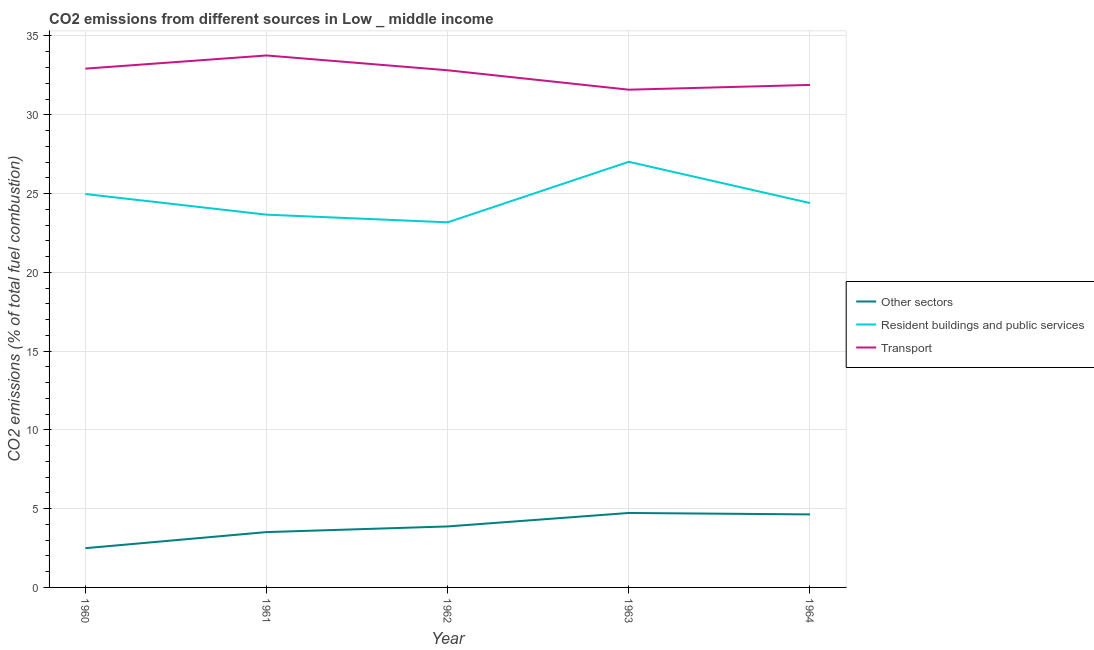Does the line corresponding to percentage of co2 emissions from resident buildings and public services intersect with the line corresponding to percentage of co2 emissions from transport?
Keep it short and to the point. No. Is the number of lines equal to the number of legend labels?
Make the answer very short. Yes. What is the percentage of co2 emissions from other sectors in 1960?
Ensure brevity in your answer.  2.49. Across all years, what is the maximum percentage of co2 emissions from other sectors?
Offer a terse response. 4.73. Across all years, what is the minimum percentage of co2 emissions from other sectors?
Your answer should be compact. 2.49. In which year was the percentage of co2 emissions from transport minimum?
Provide a succinct answer. 1963. What is the total percentage of co2 emissions from resident buildings and public services in the graph?
Keep it short and to the point. 123.22. What is the difference between the percentage of co2 emissions from transport in 1963 and that in 1964?
Your answer should be very brief. -0.3. What is the difference between the percentage of co2 emissions from other sectors in 1964 and the percentage of co2 emissions from transport in 1961?
Make the answer very short. -29.13. What is the average percentage of co2 emissions from other sectors per year?
Make the answer very short. 3.85. In the year 1960, what is the difference between the percentage of co2 emissions from resident buildings and public services and percentage of co2 emissions from other sectors?
Provide a succinct answer. 22.48. What is the ratio of the percentage of co2 emissions from transport in 1961 to that in 1963?
Ensure brevity in your answer.  1.07. Is the percentage of co2 emissions from other sectors in 1961 less than that in 1964?
Your answer should be very brief. Yes. Is the difference between the percentage of co2 emissions from other sectors in 1961 and 1963 greater than the difference between the percentage of co2 emissions from transport in 1961 and 1963?
Ensure brevity in your answer.  No. What is the difference between the highest and the second highest percentage of co2 emissions from other sectors?
Your response must be concise. 0.09. What is the difference between the highest and the lowest percentage of co2 emissions from resident buildings and public services?
Ensure brevity in your answer.  3.84. Is the sum of the percentage of co2 emissions from resident buildings and public services in 1960 and 1961 greater than the maximum percentage of co2 emissions from transport across all years?
Your answer should be compact. Yes. Is the percentage of co2 emissions from other sectors strictly greater than the percentage of co2 emissions from resident buildings and public services over the years?
Ensure brevity in your answer.  No. How many lines are there?
Offer a terse response. 3. How many years are there in the graph?
Provide a short and direct response. 5. What is the difference between two consecutive major ticks on the Y-axis?
Provide a short and direct response. 5. Does the graph contain grids?
Keep it short and to the point. Yes. Where does the legend appear in the graph?
Provide a short and direct response. Center right. How many legend labels are there?
Provide a succinct answer. 3. What is the title of the graph?
Your answer should be compact. CO2 emissions from different sources in Low _ middle income. What is the label or title of the X-axis?
Give a very brief answer. Year. What is the label or title of the Y-axis?
Your answer should be compact. CO2 emissions (% of total fuel combustion). What is the CO2 emissions (% of total fuel combustion) in Other sectors in 1960?
Your answer should be compact. 2.49. What is the CO2 emissions (% of total fuel combustion) in Resident buildings and public services in 1960?
Offer a terse response. 24.97. What is the CO2 emissions (% of total fuel combustion) of Transport in 1960?
Ensure brevity in your answer.  32.93. What is the CO2 emissions (% of total fuel combustion) in Other sectors in 1961?
Offer a very short reply. 3.51. What is the CO2 emissions (% of total fuel combustion) of Resident buildings and public services in 1961?
Offer a very short reply. 23.66. What is the CO2 emissions (% of total fuel combustion) in Transport in 1961?
Provide a succinct answer. 33.76. What is the CO2 emissions (% of total fuel combustion) in Other sectors in 1962?
Offer a very short reply. 3.87. What is the CO2 emissions (% of total fuel combustion) in Resident buildings and public services in 1962?
Your answer should be very brief. 23.17. What is the CO2 emissions (% of total fuel combustion) in Transport in 1962?
Your response must be concise. 32.82. What is the CO2 emissions (% of total fuel combustion) of Other sectors in 1963?
Offer a very short reply. 4.73. What is the CO2 emissions (% of total fuel combustion) in Resident buildings and public services in 1963?
Offer a terse response. 27.01. What is the CO2 emissions (% of total fuel combustion) in Transport in 1963?
Ensure brevity in your answer.  31.59. What is the CO2 emissions (% of total fuel combustion) of Other sectors in 1964?
Offer a terse response. 4.63. What is the CO2 emissions (% of total fuel combustion) in Resident buildings and public services in 1964?
Keep it short and to the point. 24.4. What is the CO2 emissions (% of total fuel combustion) of Transport in 1964?
Your answer should be very brief. 31.89. Across all years, what is the maximum CO2 emissions (% of total fuel combustion) of Other sectors?
Give a very brief answer. 4.73. Across all years, what is the maximum CO2 emissions (% of total fuel combustion) of Resident buildings and public services?
Your answer should be very brief. 27.01. Across all years, what is the maximum CO2 emissions (% of total fuel combustion) in Transport?
Your response must be concise. 33.76. Across all years, what is the minimum CO2 emissions (% of total fuel combustion) of Other sectors?
Your answer should be compact. 2.49. Across all years, what is the minimum CO2 emissions (% of total fuel combustion) of Resident buildings and public services?
Ensure brevity in your answer.  23.17. Across all years, what is the minimum CO2 emissions (% of total fuel combustion) in Transport?
Provide a short and direct response. 31.59. What is the total CO2 emissions (% of total fuel combustion) of Other sectors in the graph?
Make the answer very short. 19.23. What is the total CO2 emissions (% of total fuel combustion) in Resident buildings and public services in the graph?
Provide a short and direct response. 123.22. What is the total CO2 emissions (% of total fuel combustion) of Transport in the graph?
Make the answer very short. 163. What is the difference between the CO2 emissions (% of total fuel combustion) of Other sectors in 1960 and that in 1961?
Your response must be concise. -1.02. What is the difference between the CO2 emissions (% of total fuel combustion) of Resident buildings and public services in 1960 and that in 1961?
Provide a short and direct response. 1.31. What is the difference between the CO2 emissions (% of total fuel combustion) of Transport in 1960 and that in 1961?
Your response must be concise. -0.84. What is the difference between the CO2 emissions (% of total fuel combustion) in Other sectors in 1960 and that in 1962?
Make the answer very short. -1.38. What is the difference between the CO2 emissions (% of total fuel combustion) in Resident buildings and public services in 1960 and that in 1962?
Make the answer very short. 1.8. What is the difference between the CO2 emissions (% of total fuel combustion) of Transport in 1960 and that in 1962?
Give a very brief answer. 0.1. What is the difference between the CO2 emissions (% of total fuel combustion) in Other sectors in 1960 and that in 1963?
Make the answer very short. -2.24. What is the difference between the CO2 emissions (% of total fuel combustion) of Resident buildings and public services in 1960 and that in 1963?
Provide a short and direct response. -2.05. What is the difference between the CO2 emissions (% of total fuel combustion) of Transport in 1960 and that in 1963?
Your response must be concise. 1.34. What is the difference between the CO2 emissions (% of total fuel combustion) in Other sectors in 1960 and that in 1964?
Give a very brief answer. -2.14. What is the difference between the CO2 emissions (% of total fuel combustion) of Resident buildings and public services in 1960 and that in 1964?
Provide a succinct answer. 0.57. What is the difference between the CO2 emissions (% of total fuel combustion) in Transport in 1960 and that in 1964?
Offer a very short reply. 1.03. What is the difference between the CO2 emissions (% of total fuel combustion) in Other sectors in 1961 and that in 1962?
Keep it short and to the point. -0.36. What is the difference between the CO2 emissions (% of total fuel combustion) in Resident buildings and public services in 1961 and that in 1962?
Give a very brief answer. 0.49. What is the difference between the CO2 emissions (% of total fuel combustion) of Transport in 1961 and that in 1962?
Offer a terse response. 0.94. What is the difference between the CO2 emissions (% of total fuel combustion) of Other sectors in 1961 and that in 1963?
Offer a terse response. -1.21. What is the difference between the CO2 emissions (% of total fuel combustion) in Resident buildings and public services in 1961 and that in 1963?
Offer a very short reply. -3.35. What is the difference between the CO2 emissions (% of total fuel combustion) of Transport in 1961 and that in 1963?
Your response must be concise. 2.17. What is the difference between the CO2 emissions (% of total fuel combustion) in Other sectors in 1961 and that in 1964?
Your response must be concise. -1.12. What is the difference between the CO2 emissions (% of total fuel combustion) in Resident buildings and public services in 1961 and that in 1964?
Your answer should be very brief. -0.74. What is the difference between the CO2 emissions (% of total fuel combustion) in Transport in 1961 and that in 1964?
Ensure brevity in your answer.  1.87. What is the difference between the CO2 emissions (% of total fuel combustion) of Other sectors in 1962 and that in 1963?
Give a very brief answer. -0.85. What is the difference between the CO2 emissions (% of total fuel combustion) in Resident buildings and public services in 1962 and that in 1963?
Provide a succinct answer. -3.84. What is the difference between the CO2 emissions (% of total fuel combustion) of Transport in 1962 and that in 1963?
Offer a terse response. 1.23. What is the difference between the CO2 emissions (% of total fuel combustion) in Other sectors in 1962 and that in 1964?
Keep it short and to the point. -0.76. What is the difference between the CO2 emissions (% of total fuel combustion) in Resident buildings and public services in 1962 and that in 1964?
Your answer should be very brief. -1.22. What is the difference between the CO2 emissions (% of total fuel combustion) in Transport in 1962 and that in 1964?
Keep it short and to the point. 0.93. What is the difference between the CO2 emissions (% of total fuel combustion) in Other sectors in 1963 and that in 1964?
Provide a succinct answer. 0.09. What is the difference between the CO2 emissions (% of total fuel combustion) in Resident buildings and public services in 1963 and that in 1964?
Ensure brevity in your answer.  2.62. What is the difference between the CO2 emissions (% of total fuel combustion) of Transport in 1963 and that in 1964?
Offer a terse response. -0.3. What is the difference between the CO2 emissions (% of total fuel combustion) in Other sectors in 1960 and the CO2 emissions (% of total fuel combustion) in Resident buildings and public services in 1961?
Your answer should be compact. -21.17. What is the difference between the CO2 emissions (% of total fuel combustion) of Other sectors in 1960 and the CO2 emissions (% of total fuel combustion) of Transport in 1961?
Provide a short and direct response. -31.27. What is the difference between the CO2 emissions (% of total fuel combustion) of Resident buildings and public services in 1960 and the CO2 emissions (% of total fuel combustion) of Transport in 1961?
Your answer should be compact. -8.79. What is the difference between the CO2 emissions (% of total fuel combustion) in Other sectors in 1960 and the CO2 emissions (% of total fuel combustion) in Resident buildings and public services in 1962?
Provide a succinct answer. -20.68. What is the difference between the CO2 emissions (% of total fuel combustion) in Other sectors in 1960 and the CO2 emissions (% of total fuel combustion) in Transport in 1962?
Provide a short and direct response. -30.33. What is the difference between the CO2 emissions (% of total fuel combustion) in Resident buildings and public services in 1960 and the CO2 emissions (% of total fuel combustion) in Transport in 1962?
Provide a short and direct response. -7.85. What is the difference between the CO2 emissions (% of total fuel combustion) in Other sectors in 1960 and the CO2 emissions (% of total fuel combustion) in Resident buildings and public services in 1963?
Provide a short and direct response. -24.52. What is the difference between the CO2 emissions (% of total fuel combustion) of Other sectors in 1960 and the CO2 emissions (% of total fuel combustion) of Transport in 1963?
Offer a very short reply. -29.1. What is the difference between the CO2 emissions (% of total fuel combustion) in Resident buildings and public services in 1960 and the CO2 emissions (% of total fuel combustion) in Transport in 1963?
Offer a very short reply. -6.62. What is the difference between the CO2 emissions (% of total fuel combustion) of Other sectors in 1960 and the CO2 emissions (% of total fuel combustion) of Resident buildings and public services in 1964?
Your response must be concise. -21.91. What is the difference between the CO2 emissions (% of total fuel combustion) of Other sectors in 1960 and the CO2 emissions (% of total fuel combustion) of Transport in 1964?
Keep it short and to the point. -29.4. What is the difference between the CO2 emissions (% of total fuel combustion) of Resident buildings and public services in 1960 and the CO2 emissions (% of total fuel combustion) of Transport in 1964?
Ensure brevity in your answer.  -6.92. What is the difference between the CO2 emissions (% of total fuel combustion) in Other sectors in 1961 and the CO2 emissions (% of total fuel combustion) in Resident buildings and public services in 1962?
Offer a very short reply. -19.66. What is the difference between the CO2 emissions (% of total fuel combustion) in Other sectors in 1961 and the CO2 emissions (% of total fuel combustion) in Transport in 1962?
Provide a succinct answer. -29.31. What is the difference between the CO2 emissions (% of total fuel combustion) in Resident buildings and public services in 1961 and the CO2 emissions (% of total fuel combustion) in Transport in 1962?
Make the answer very short. -9.16. What is the difference between the CO2 emissions (% of total fuel combustion) of Other sectors in 1961 and the CO2 emissions (% of total fuel combustion) of Resident buildings and public services in 1963?
Your answer should be compact. -23.5. What is the difference between the CO2 emissions (% of total fuel combustion) of Other sectors in 1961 and the CO2 emissions (% of total fuel combustion) of Transport in 1963?
Your response must be concise. -28.08. What is the difference between the CO2 emissions (% of total fuel combustion) of Resident buildings and public services in 1961 and the CO2 emissions (% of total fuel combustion) of Transport in 1963?
Offer a very short reply. -7.93. What is the difference between the CO2 emissions (% of total fuel combustion) in Other sectors in 1961 and the CO2 emissions (% of total fuel combustion) in Resident buildings and public services in 1964?
Offer a very short reply. -20.89. What is the difference between the CO2 emissions (% of total fuel combustion) of Other sectors in 1961 and the CO2 emissions (% of total fuel combustion) of Transport in 1964?
Ensure brevity in your answer.  -28.38. What is the difference between the CO2 emissions (% of total fuel combustion) of Resident buildings and public services in 1961 and the CO2 emissions (% of total fuel combustion) of Transport in 1964?
Your response must be concise. -8.23. What is the difference between the CO2 emissions (% of total fuel combustion) in Other sectors in 1962 and the CO2 emissions (% of total fuel combustion) in Resident buildings and public services in 1963?
Keep it short and to the point. -23.14. What is the difference between the CO2 emissions (% of total fuel combustion) of Other sectors in 1962 and the CO2 emissions (% of total fuel combustion) of Transport in 1963?
Your answer should be compact. -27.72. What is the difference between the CO2 emissions (% of total fuel combustion) of Resident buildings and public services in 1962 and the CO2 emissions (% of total fuel combustion) of Transport in 1963?
Provide a short and direct response. -8.42. What is the difference between the CO2 emissions (% of total fuel combustion) in Other sectors in 1962 and the CO2 emissions (% of total fuel combustion) in Resident buildings and public services in 1964?
Your answer should be very brief. -20.53. What is the difference between the CO2 emissions (% of total fuel combustion) in Other sectors in 1962 and the CO2 emissions (% of total fuel combustion) in Transport in 1964?
Provide a succinct answer. -28.02. What is the difference between the CO2 emissions (% of total fuel combustion) of Resident buildings and public services in 1962 and the CO2 emissions (% of total fuel combustion) of Transport in 1964?
Provide a succinct answer. -8.72. What is the difference between the CO2 emissions (% of total fuel combustion) in Other sectors in 1963 and the CO2 emissions (% of total fuel combustion) in Resident buildings and public services in 1964?
Offer a very short reply. -19.67. What is the difference between the CO2 emissions (% of total fuel combustion) in Other sectors in 1963 and the CO2 emissions (% of total fuel combustion) in Transport in 1964?
Your response must be concise. -27.17. What is the difference between the CO2 emissions (% of total fuel combustion) in Resident buildings and public services in 1963 and the CO2 emissions (% of total fuel combustion) in Transport in 1964?
Provide a succinct answer. -4.88. What is the average CO2 emissions (% of total fuel combustion) of Other sectors per year?
Give a very brief answer. 3.85. What is the average CO2 emissions (% of total fuel combustion) in Resident buildings and public services per year?
Your answer should be compact. 24.64. What is the average CO2 emissions (% of total fuel combustion) of Transport per year?
Offer a terse response. 32.6. In the year 1960, what is the difference between the CO2 emissions (% of total fuel combustion) in Other sectors and CO2 emissions (% of total fuel combustion) in Resident buildings and public services?
Your response must be concise. -22.48. In the year 1960, what is the difference between the CO2 emissions (% of total fuel combustion) of Other sectors and CO2 emissions (% of total fuel combustion) of Transport?
Keep it short and to the point. -30.44. In the year 1960, what is the difference between the CO2 emissions (% of total fuel combustion) in Resident buildings and public services and CO2 emissions (% of total fuel combustion) in Transport?
Your answer should be compact. -7.96. In the year 1961, what is the difference between the CO2 emissions (% of total fuel combustion) of Other sectors and CO2 emissions (% of total fuel combustion) of Resident buildings and public services?
Offer a terse response. -20.15. In the year 1961, what is the difference between the CO2 emissions (% of total fuel combustion) in Other sectors and CO2 emissions (% of total fuel combustion) in Transport?
Your answer should be compact. -30.25. In the year 1961, what is the difference between the CO2 emissions (% of total fuel combustion) in Resident buildings and public services and CO2 emissions (% of total fuel combustion) in Transport?
Your answer should be very brief. -10.1. In the year 1962, what is the difference between the CO2 emissions (% of total fuel combustion) in Other sectors and CO2 emissions (% of total fuel combustion) in Resident buildings and public services?
Provide a short and direct response. -19.3. In the year 1962, what is the difference between the CO2 emissions (% of total fuel combustion) of Other sectors and CO2 emissions (% of total fuel combustion) of Transport?
Give a very brief answer. -28.95. In the year 1962, what is the difference between the CO2 emissions (% of total fuel combustion) in Resident buildings and public services and CO2 emissions (% of total fuel combustion) in Transport?
Your answer should be compact. -9.65. In the year 1963, what is the difference between the CO2 emissions (% of total fuel combustion) in Other sectors and CO2 emissions (% of total fuel combustion) in Resident buildings and public services?
Make the answer very short. -22.29. In the year 1963, what is the difference between the CO2 emissions (% of total fuel combustion) of Other sectors and CO2 emissions (% of total fuel combustion) of Transport?
Ensure brevity in your answer.  -26.87. In the year 1963, what is the difference between the CO2 emissions (% of total fuel combustion) of Resident buildings and public services and CO2 emissions (% of total fuel combustion) of Transport?
Your answer should be very brief. -4.58. In the year 1964, what is the difference between the CO2 emissions (% of total fuel combustion) in Other sectors and CO2 emissions (% of total fuel combustion) in Resident buildings and public services?
Make the answer very short. -19.76. In the year 1964, what is the difference between the CO2 emissions (% of total fuel combustion) of Other sectors and CO2 emissions (% of total fuel combustion) of Transport?
Keep it short and to the point. -27.26. In the year 1964, what is the difference between the CO2 emissions (% of total fuel combustion) in Resident buildings and public services and CO2 emissions (% of total fuel combustion) in Transport?
Give a very brief answer. -7.5. What is the ratio of the CO2 emissions (% of total fuel combustion) in Other sectors in 1960 to that in 1961?
Provide a short and direct response. 0.71. What is the ratio of the CO2 emissions (% of total fuel combustion) in Resident buildings and public services in 1960 to that in 1961?
Your answer should be very brief. 1.06. What is the ratio of the CO2 emissions (% of total fuel combustion) in Transport in 1960 to that in 1961?
Give a very brief answer. 0.98. What is the ratio of the CO2 emissions (% of total fuel combustion) in Other sectors in 1960 to that in 1962?
Make the answer very short. 0.64. What is the ratio of the CO2 emissions (% of total fuel combustion) of Resident buildings and public services in 1960 to that in 1962?
Keep it short and to the point. 1.08. What is the ratio of the CO2 emissions (% of total fuel combustion) of Other sectors in 1960 to that in 1963?
Make the answer very short. 0.53. What is the ratio of the CO2 emissions (% of total fuel combustion) in Resident buildings and public services in 1960 to that in 1963?
Your answer should be compact. 0.92. What is the ratio of the CO2 emissions (% of total fuel combustion) in Transport in 1960 to that in 1963?
Ensure brevity in your answer.  1.04. What is the ratio of the CO2 emissions (% of total fuel combustion) of Other sectors in 1960 to that in 1964?
Give a very brief answer. 0.54. What is the ratio of the CO2 emissions (% of total fuel combustion) of Resident buildings and public services in 1960 to that in 1964?
Offer a very short reply. 1.02. What is the ratio of the CO2 emissions (% of total fuel combustion) of Transport in 1960 to that in 1964?
Offer a terse response. 1.03. What is the ratio of the CO2 emissions (% of total fuel combustion) of Other sectors in 1961 to that in 1962?
Make the answer very short. 0.91. What is the ratio of the CO2 emissions (% of total fuel combustion) in Transport in 1961 to that in 1962?
Provide a short and direct response. 1.03. What is the ratio of the CO2 emissions (% of total fuel combustion) in Other sectors in 1961 to that in 1963?
Give a very brief answer. 0.74. What is the ratio of the CO2 emissions (% of total fuel combustion) in Resident buildings and public services in 1961 to that in 1963?
Offer a very short reply. 0.88. What is the ratio of the CO2 emissions (% of total fuel combustion) in Transport in 1961 to that in 1963?
Your answer should be very brief. 1.07. What is the ratio of the CO2 emissions (% of total fuel combustion) in Other sectors in 1961 to that in 1964?
Your response must be concise. 0.76. What is the ratio of the CO2 emissions (% of total fuel combustion) of Resident buildings and public services in 1961 to that in 1964?
Provide a succinct answer. 0.97. What is the ratio of the CO2 emissions (% of total fuel combustion) in Transport in 1961 to that in 1964?
Make the answer very short. 1.06. What is the ratio of the CO2 emissions (% of total fuel combustion) in Other sectors in 1962 to that in 1963?
Offer a very short reply. 0.82. What is the ratio of the CO2 emissions (% of total fuel combustion) of Resident buildings and public services in 1962 to that in 1963?
Provide a succinct answer. 0.86. What is the ratio of the CO2 emissions (% of total fuel combustion) of Transport in 1962 to that in 1963?
Provide a short and direct response. 1.04. What is the ratio of the CO2 emissions (% of total fuel combustion) in Other sectors in 1962 to that in 1964?
Make the answer very short. 0.84. What is the ratio of the CO2 emissions (% of total fuel combustion) in Resident buildings and public services in 1962 to that in 1964?
Provide a short and direct response. 0.95. What is the ratio of the CO2 emissions (% of total fuel combustion) of Transport in 1962 to that in 1964?
Keep it short and to the point. 1.03. What is the ratio of the CO2 emissions (% of total fuel combustion) of Other sectors in 1963 to that in 1964?
Provide a succinct answer. 1.02. What is the ratio of the CO2 emissions (% of total fuel combustion) in Resident buildings and public services in 1963 to that in 1964?
Ensure brevity in your answer.  1.11. What is the ratio of the CO2 emissions (% of total fuel combustion) of Transport in 1963 to that in 1964?
Make the answer very short. 0.99. What is the difference between the highest and the second highest CO2 emissions (% of total fuel combustion) in Other sectors?
Your answer should be very brief. 0.09. What is the difference between the highest and the second highest CO2 emissions (% of total fuel combustion) in Resident buildings and public services?
Make the answer very short. 2.05. What is the difference between the highest and the second highest CO2 emissions (% of total fuel combustion) of Transport?
Offer a terse response. 0.84. What is the difference between the highest and the lowest CO2 emissions (% of total fuel combustion) of Other sectors?
Your answer should be compact. 2.24. What is the difference between the highest and the lowest CO2 emissions (% of total fuel combustion) of Resident buildings and public services?
Ensure brevity in your answer.  3.84. What is the difference between the highest and the lowest CO2 emissions (% of total fuel combustion) of Transport?
Ensure brevity in your answer.  2.17. 